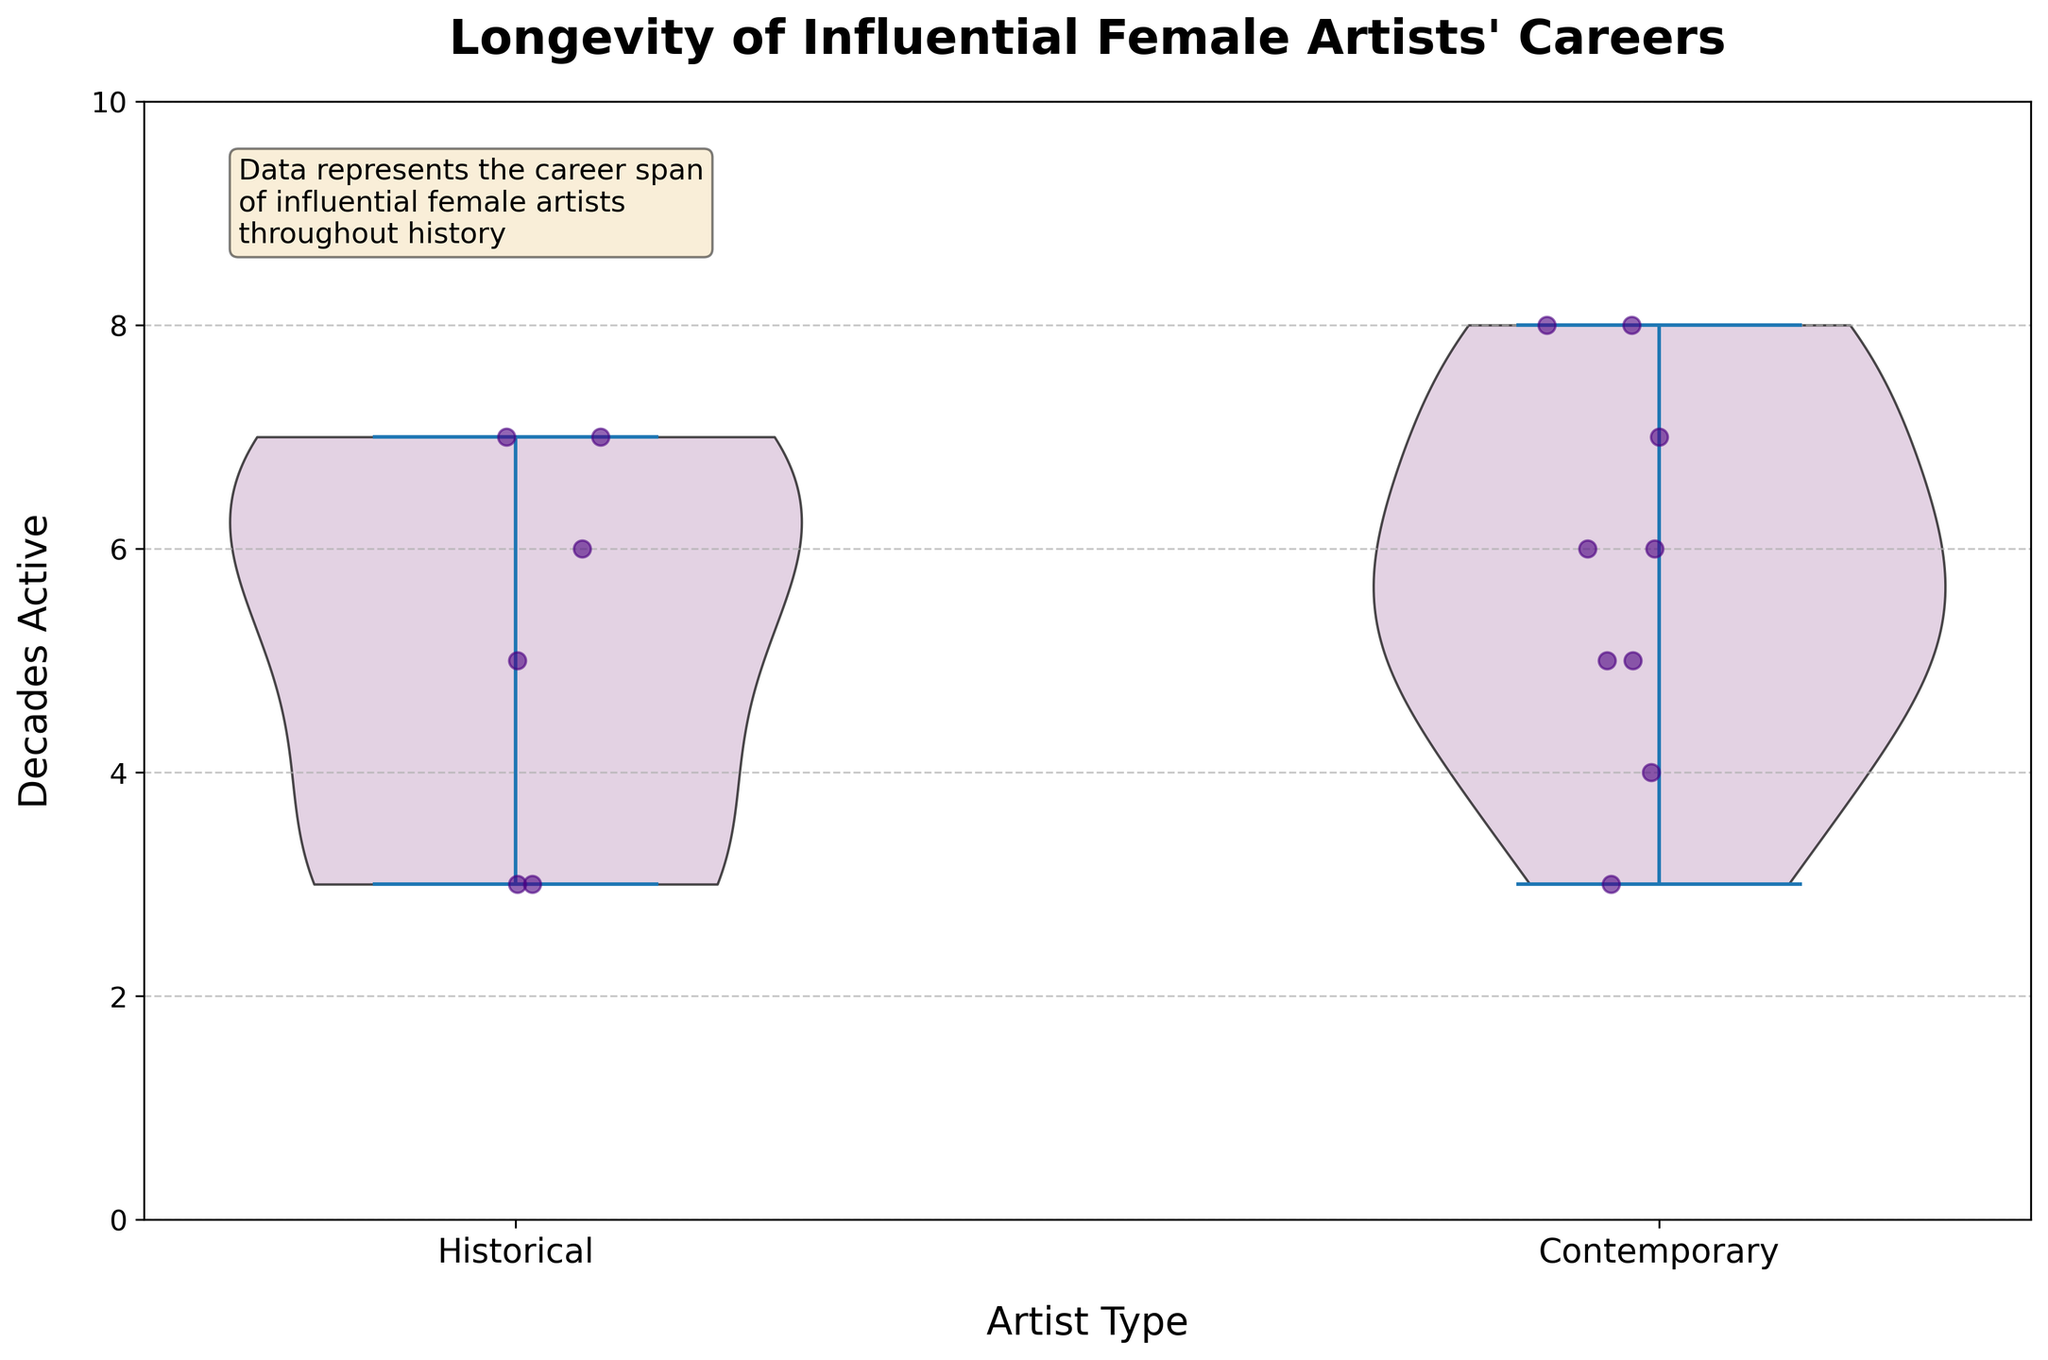What's the title of the plot? The title is shown at the top of the plot. It reads, "Longevity of Influential Female Artists' Careers."
Answer: Longevity of Influential Female Artists' Careers What are the two categories of artists shown on the x-axis? The x-axis has two labeled categories which are "Historical" and "Contemporary".
Answer: Historical, Contemporary What is the maximum number of decades an artist has been active according to the plot? The y-axis goes up to 10 decades, but we need to see the highest plotted point or the extent of the violin plot, which shows that some artists have been active for up to 8 decades.
Answer: 8 Which category of artists has a wider range of active decades according to the plot? The Historical and Contemporary categories both show active decades up to 8, but Contemporary artists show a slightly more spread distribution, indicating a wider range.
Answer: Contemporary How many historical artists are shown in the plot? We count the individual jittered points within the "Historical" category. From the scatter points, there are 6 historical artists.
Answer: 6 What is the average decades of activity for historical artists? Add the decades active for historical artists (5 + 6 + 3 + 7 + 3 + 7) = 31, then divide by the number of historical artists (31/6).
Answer: About 5.17 decades Which group has a higher median number of decades of activity? Visually look at the violin plots' median range. The median appears higher for Contemporary artists compared to Historical artists.
Answer: Contemporary For artists active for 7 or more decades, which category do they belong to? From the scatter points and violin plot, artists with 7 or more decades are visible in both categories, indicating representation in both Historical and Contemporary artists.
Answer: Both Are there any contemporary artists active for fewer than 4 decades? From the scatter points within the "Contemporary" category, all points appear above the 4-decades mark, so there are no contemporary artists active for fewer than 4 decades in the plot.
Answer: No 